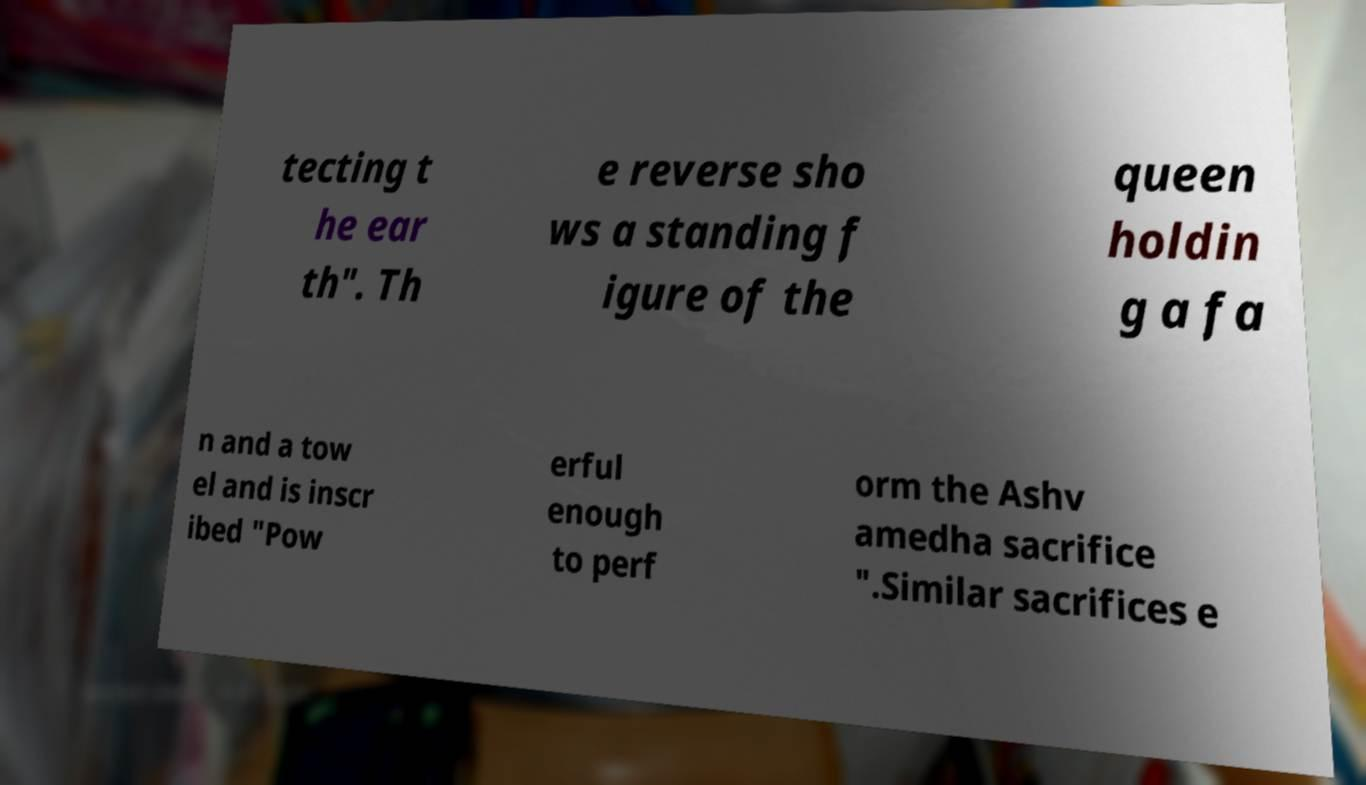Can you read and provide the text displayed in the image?This photo seems to have some interesting text. Can you extract and type it out for me? tecting t he ear th". Th e reverse sho ws a standing f igure of the queen holdin g a fa n and a tow el and is inscr ibed "Pow erful enough to perf orm the Ashv amedha sacrifice ".Similar sacrifices e 